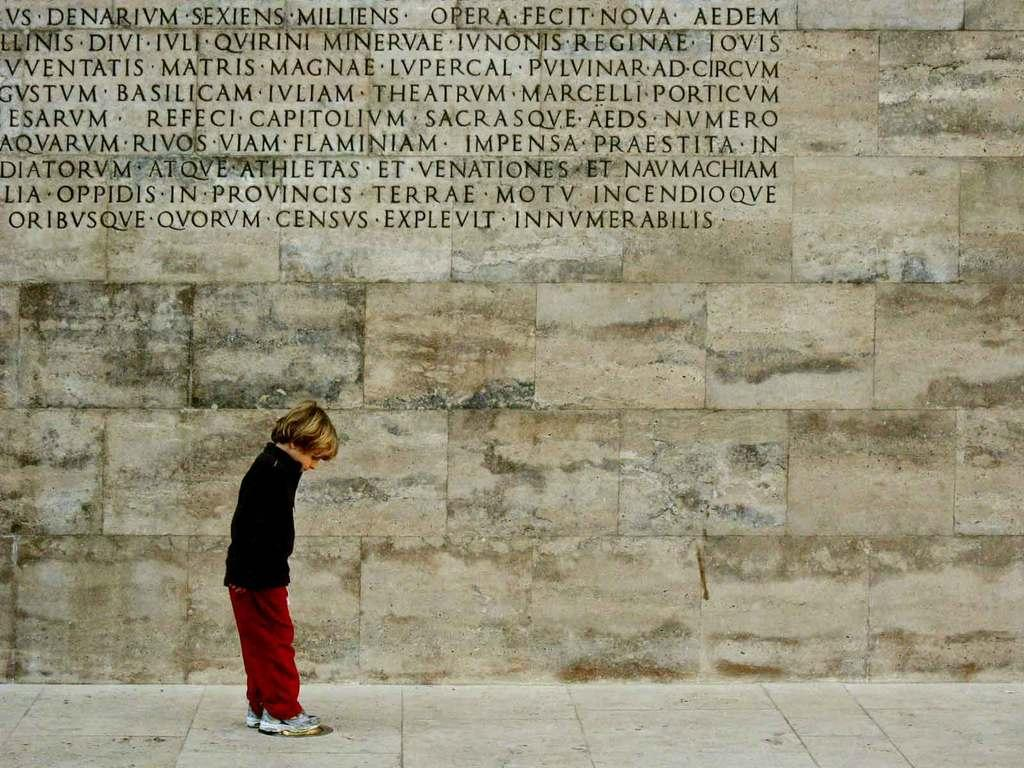Who is the main subject in the image? There is a boy in the image. What is the boy wearing? The boy is wearing a black shirt. Where is the boy located in the image? The boy is standing on the floor. What can be seen in the background of the image? There is a wall in the background of the image. What is written or carved on the wall? The wall has text carved on it. What type of horn can be seen in the boy's hand in the image? There is no horn present in the boy's hand or in the image. What kind of party is the boy attending in the image? There is no indication of a party or any social event in the image. 